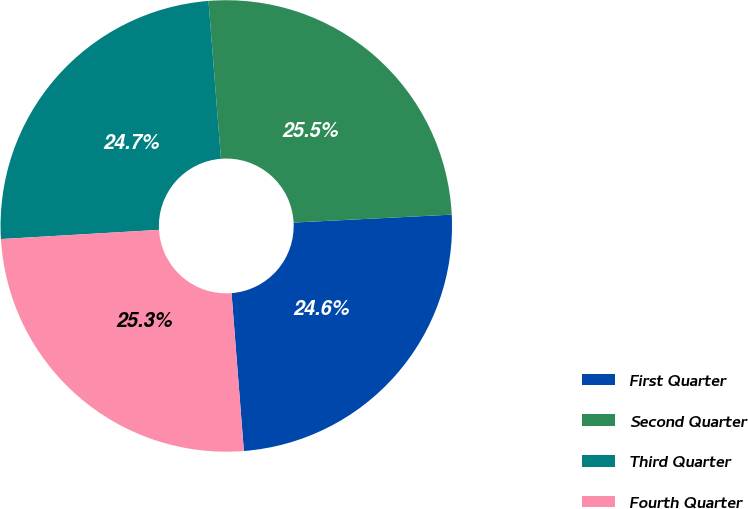Convert chart. <chart><loc_0><loc_0><loc_500><loc_500><pie_chart><fcel>First Quarter<fcel>Second Quarter<fcel>Third Quarter<fcel>Fourth Quarter<nl><fcel>24.56%<fcel>25.46%<fcel>24.67%<fcel>25.32%<nl></chart> 